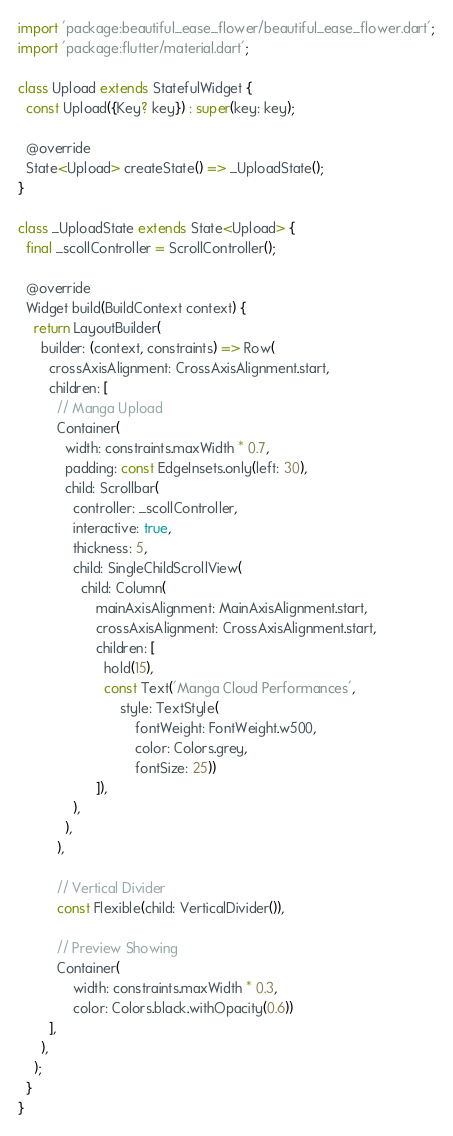<code> <loc_0><loc_0><loc_500><loc_500><_Dart_>import 'package:beautiful_ease_flower/beautiful_ease_flower.dart';
import 'package:flutter/material.dart';

class Upload extends StatefulWidget {
  const Upload({Key? key}) : super(key: key);

  @override
  State<Upload> createState() => _UploadState();
}

class _UploadState extends State<Upload> {
  final _scollController = ScrollController();

  @override
  Widget build(BuildContext context) {
    return LayoutBuilder(
      builder: (context, constraints) => Row(
        crossAxisAlignment: CrossAxisAlignment.start,
        children: [
          // Manga Upload
          Container(
            width: constraints.maxWidth * 0.7,
            padding: const EdgeInsets.only(left: 30),
            child: Scrollbar(
              controller: _scollController,
              interactive: true,
              thickness: 5,
              child: SingleChildScrollView(
                child: Column(
                    mainAxisAlignment: MainAxisAlignment.start,
                    crossAxisAlignment: CrossAxisAlignment.start,
                    children: [
                      hold(15),
                      const Text('Manga Cloud Performances',
                          style: TextStyle(
                              fontWeight: FontWeight.w500,
                              color: Colors.grey,
                              fontSize: 25))
                    ]),
              ),
            ),
          ),

          // Vertical Divider
          const Flexible(child: VerticalDivider()),

          // Preview Showing
          Container(
              width: constraints.maxWidth * 0.3,
              color: Colors.black.withOpacity(0.6))
        ],
      ),
    );
  }
}
</code> 